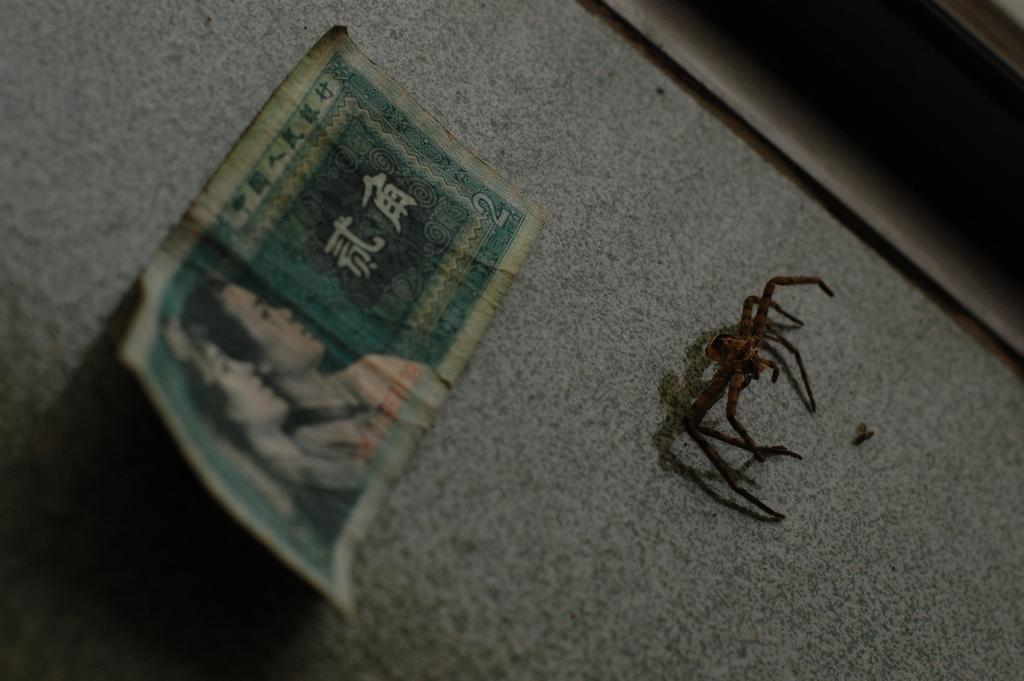What is the main subject of the image? There is a spider in the image. What else can be seen on the ground in the image? There is a currency note on the ground in the image. Can you describe the unspecified object in the image? Unfortunately, the facts provided do not give any details about the unspecified object, so we cannot describe it. What flavor of drug is the spider holding in the image? There is no drug present in the image, and the spider is not holding anything. 